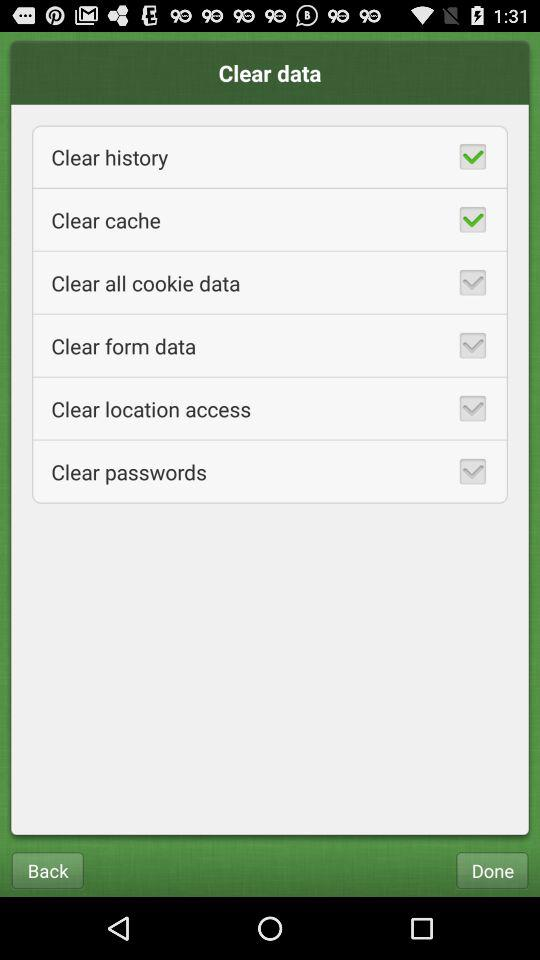What is the status of clear history? The status is on. 